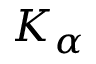<formula> <loc_0><loc_0><loc_500><loc_500>K _ { \alpha }</formula> 